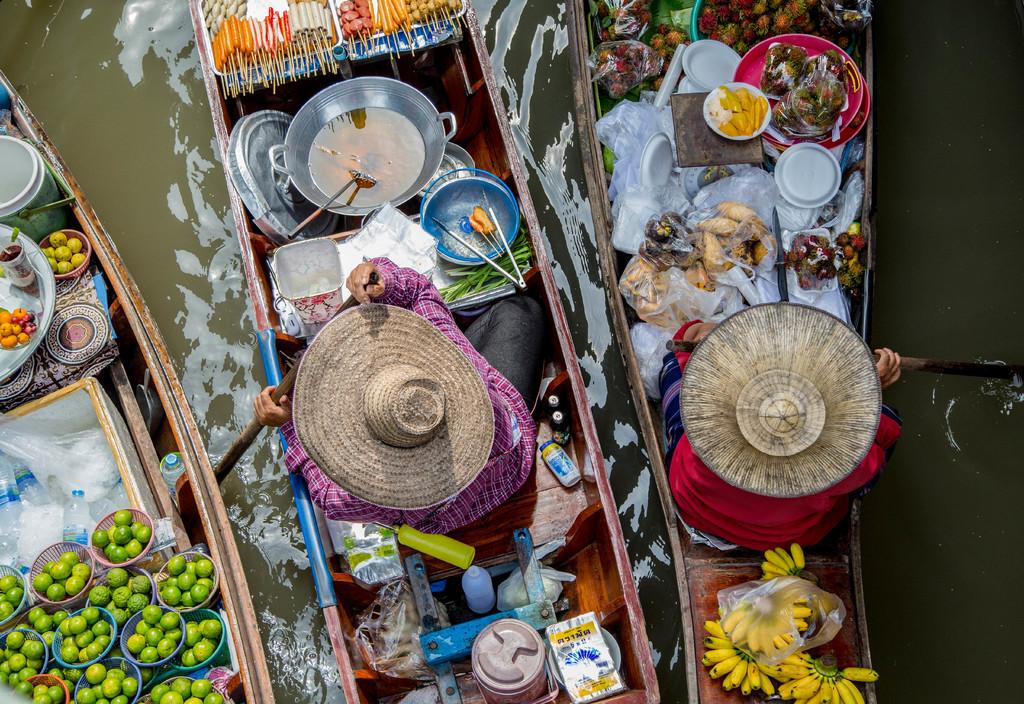What type of vehicles can be seen in the image? There are boats in the image. Can you describe the people in the image? There are persons in the image. What objects are present in the image that might be used for holding or serving food? There are bowls in the image. What type of food items are visible in the image? There are fruits in the image. What containers can be seen in the image that might hold liquids? There are bottles in the image. Where is the sofa located in the image? There is no sofa present in the image. What type of shoe can be seen on the person in the image? There are no shoes visible in the image, as it only shows boats, persons, bowls, fruits, and bottles. 